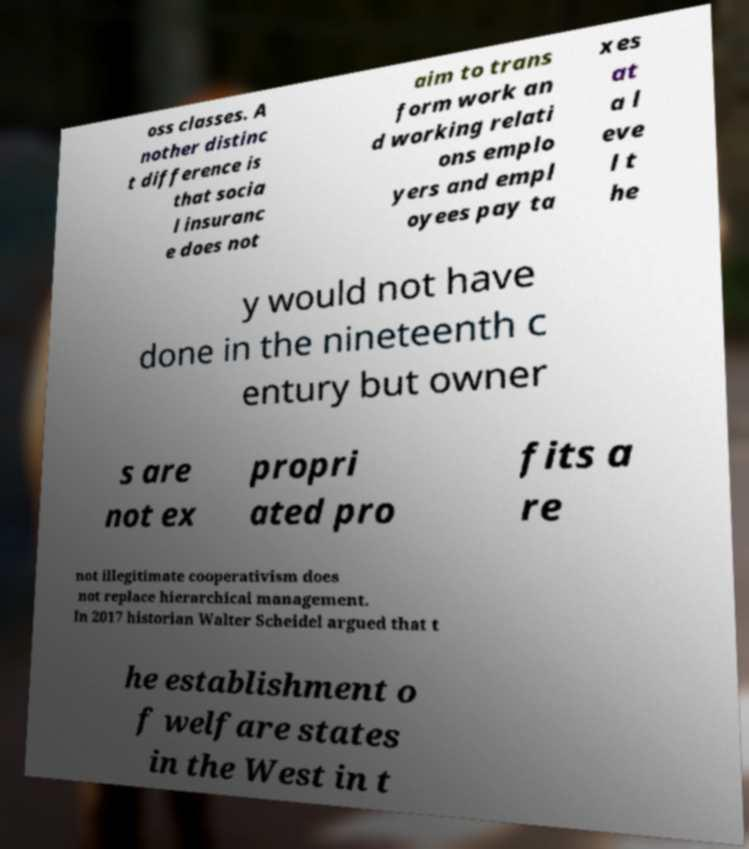Please read and relay the text visible in this image. What does it say? oss classes. A nother distinc t difference is that socia l insuranc e does not aim to trans form work an d working relati ons emplo yers and empl oyees pay ta xes at a l eve l t he y would not have done in the nineteenth c entury but owner s are not ex propri ated pro fits a re not illegitimate cooperativism does not replace hierarchical management. In 2017 historian Walter Scheidel argued that t he establishment o f welfare states in the West in t 